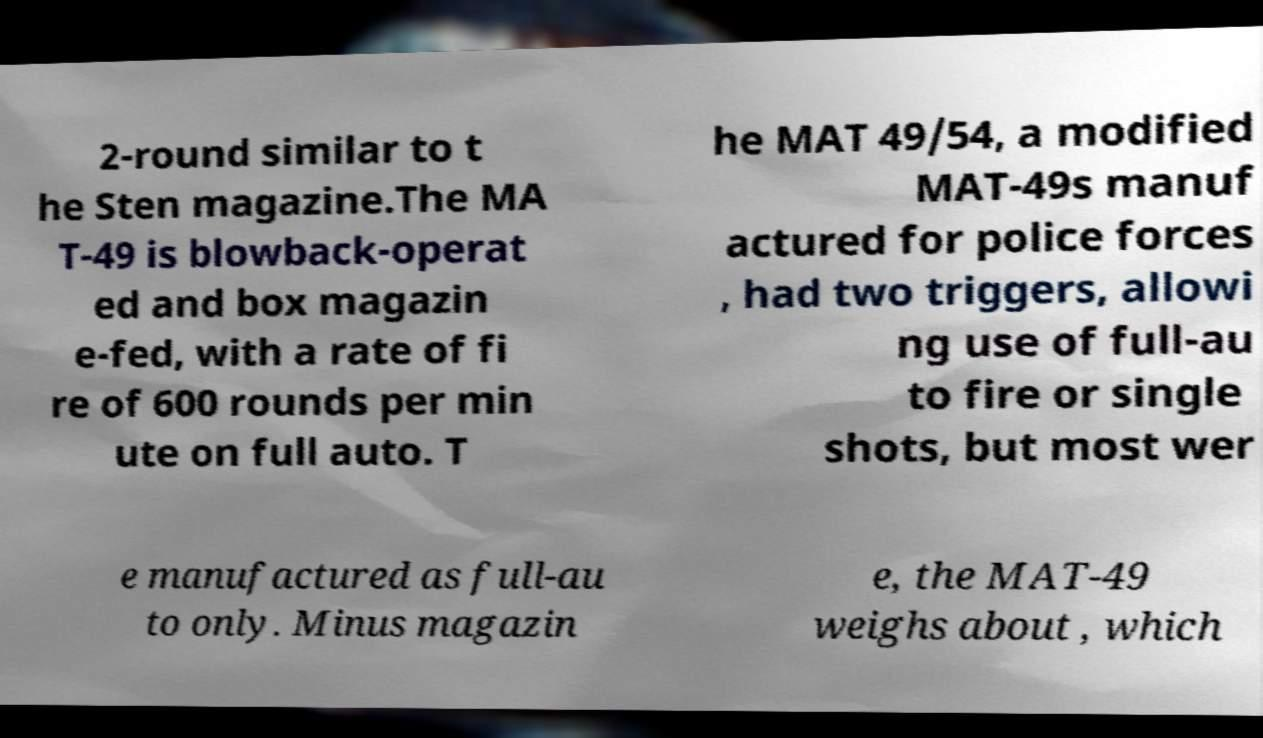What messages or text are displayed in this image? I need them in a readable, typed format. 2-round similar to t he Sten magazine.The MA T-49 is blowback-operat ed and box magazin e-fed, with a rate of fi re of 600 rounds per min ute on full auto. T he MAT 49/54, a modified MAT-49s manuf actured for police forces , had two triggers, allowi ng use of full-au to fire or single shots, but most wer e manufactured as full-au to only. Minus magazin e, the MAT-49 weighs about , which 